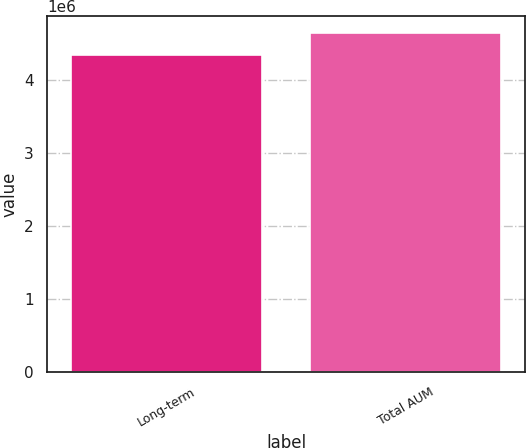<chart> <loc_0><loc_0><loc_500><loc_500><bar_chart><fcel>Long-term<fcel>Total AUM<nl><fcel>4.33532e+06<fcel>4.64541e+06<nl></chart> 